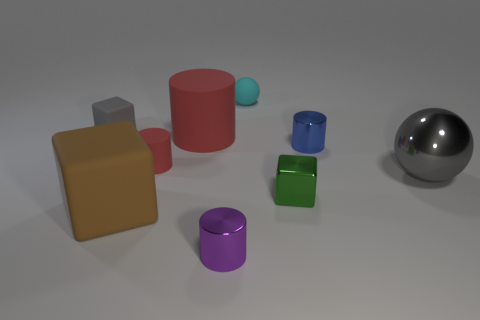Subtract all purple cubes. How many red cylinders are left? 2 Subtract all gray rubber blocks. How many blocks are left? 2 Add 1 large yellow metal cylinders. How many objects exist? 10 Subtract 2 cylinders. How many cylinders are left? 2 Subtract all purple cylinders. How many cylinders are left? 3 Subtract all blue cylinders. Subtract all blue blocks. How many cylinders are left? 3 Subtract all blocks. How many objects are left? 6 Subtract 0 blue cubes. How many objects are left? 9 Subtract all big cubes. Subtract all red matte things. How many objects are left? 6 Add 5 brown matte cubes. How many brown matte cubes are left? 6 